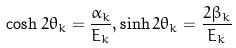<formula> <loc_0><loc_0><loc_500><loc_500>\cosh 2 \theta _ { k } = \frac { \alpha _ { k } } { E _ { k } } , \sinh 2 \theta _ { k } = \frac { 2 \beta _ { k } } { E _ { k } }</formula> 